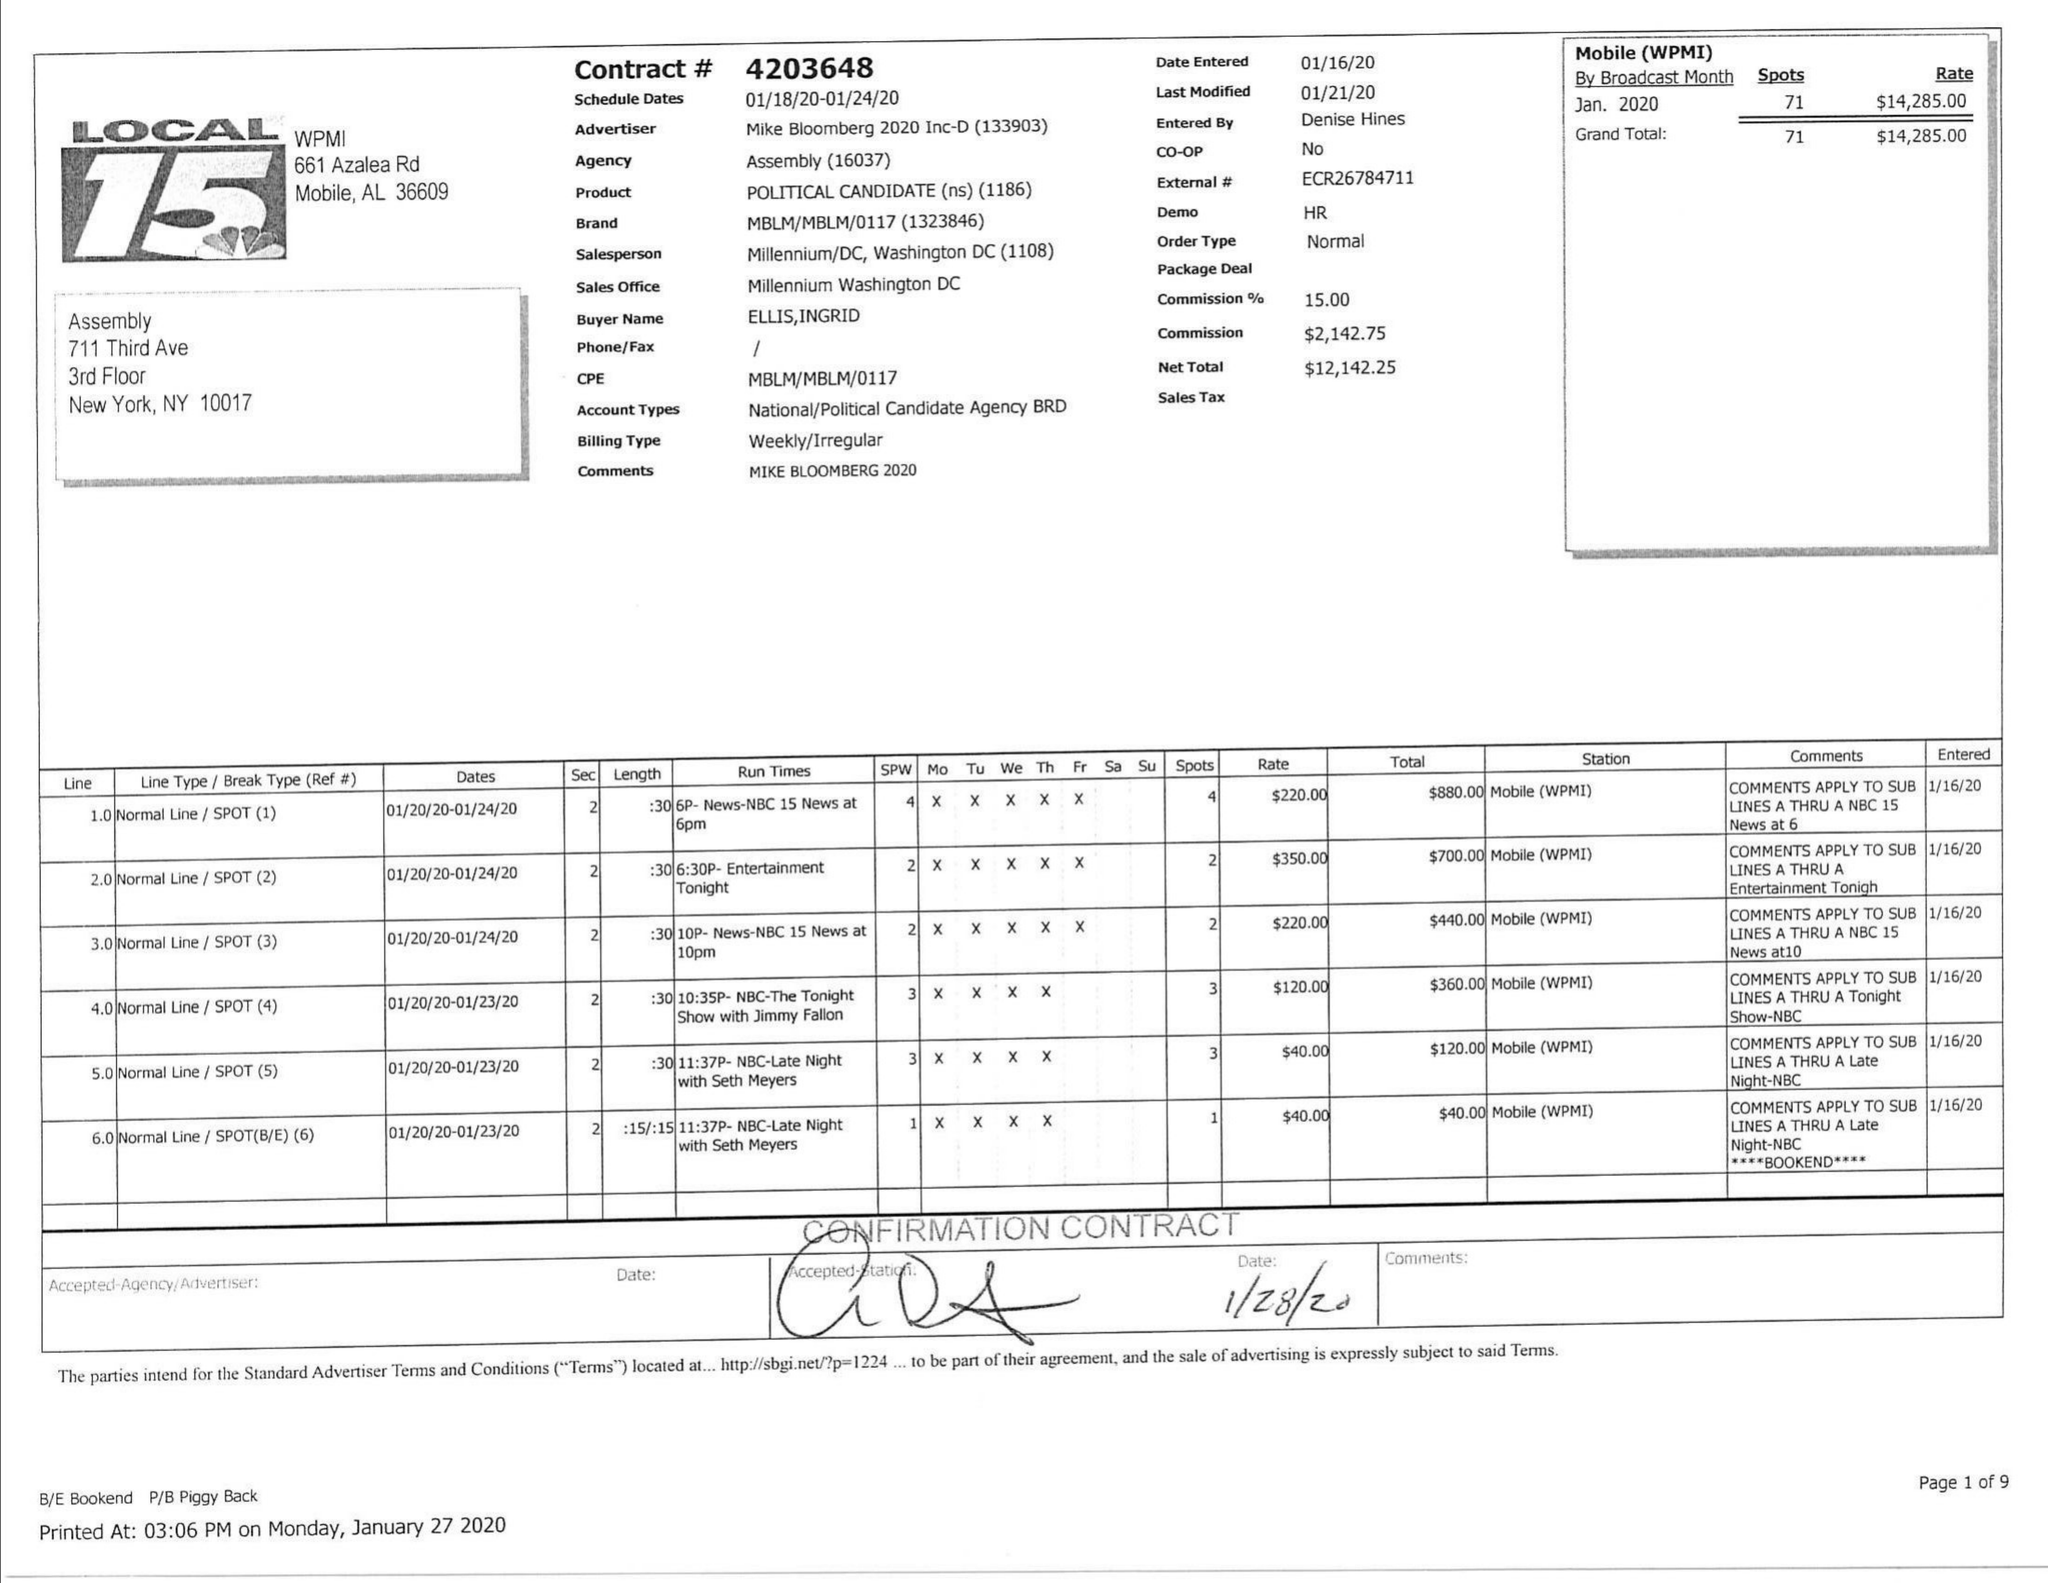What is the value for the flight_from?
Answer the question using a single word or phrase. 01/18/20 